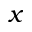<formula> <loc_0><loc_0><loc_500><loc_500>x</formula> 